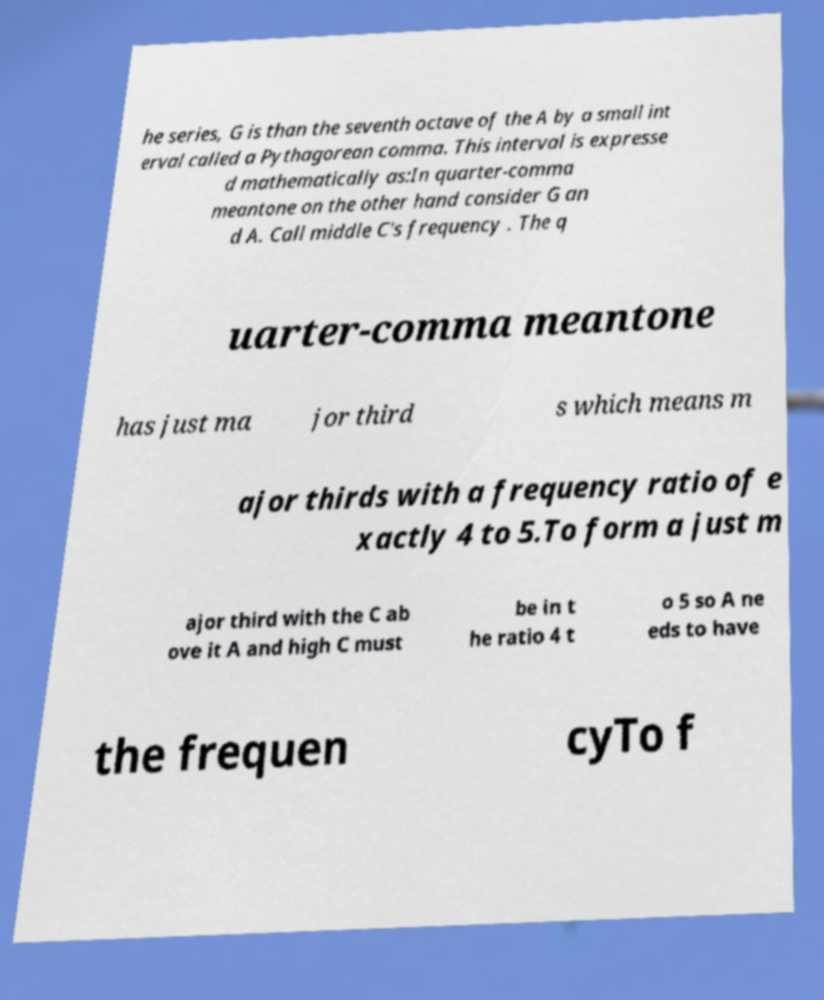For documentation purposes, I need the text within this image transcribed. Could you provide that? he series, G is than the seventh octave of the A by a small int erval called a Pythagorean comma. This interval is expresse d mathematically as:In quarter-comma meantone on the other hand consider G an d A. Call middle C's frequency . The q uarter-comma meantone has just ma jor third s which means m ajor thirds with a frequency ratio of e xactly 4 to 5.To form a just m ajor third with the C ab ove it A and high C must be in t he ratio 4 t o 5 so A ne eds to have the frequen cyTo f 